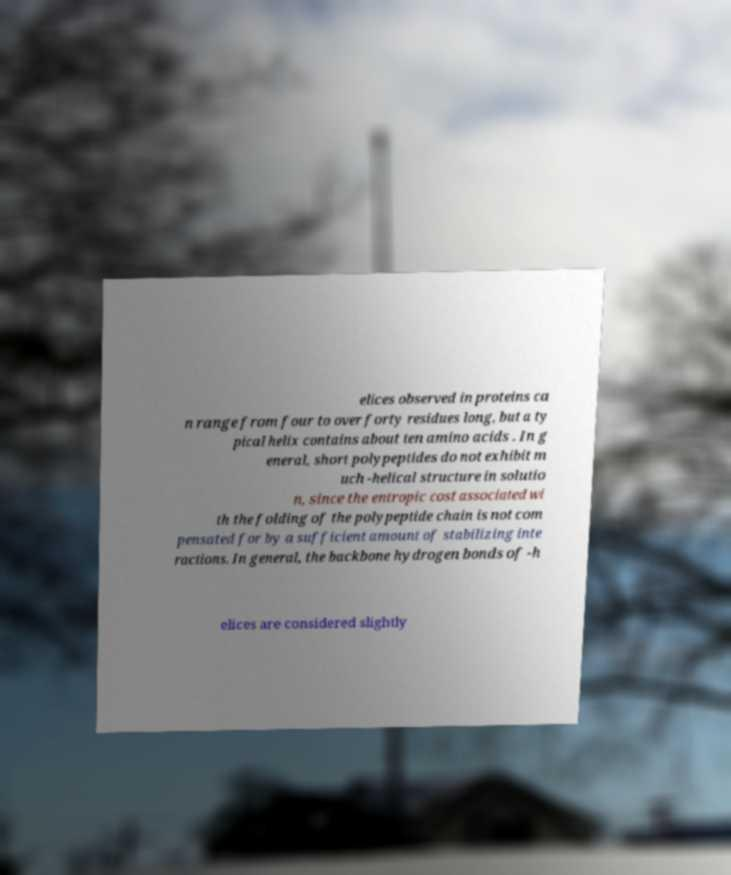Can you accurately transcribe the text from the provided image for me? elices observed in proteins ca n range from four to over forty residues long, but a ty pical helix contains about ten amino acids . In g eneral, short polypeptides do not exhibit m uch -helical structure in solutio n, since the entropic cost associated wi th the folding of the polypeptide chain is not com pensated for by a sufficient amount of stabilizing inte ractions. In general, the backbone hydrogen bonds of -h elices are considered slightly 